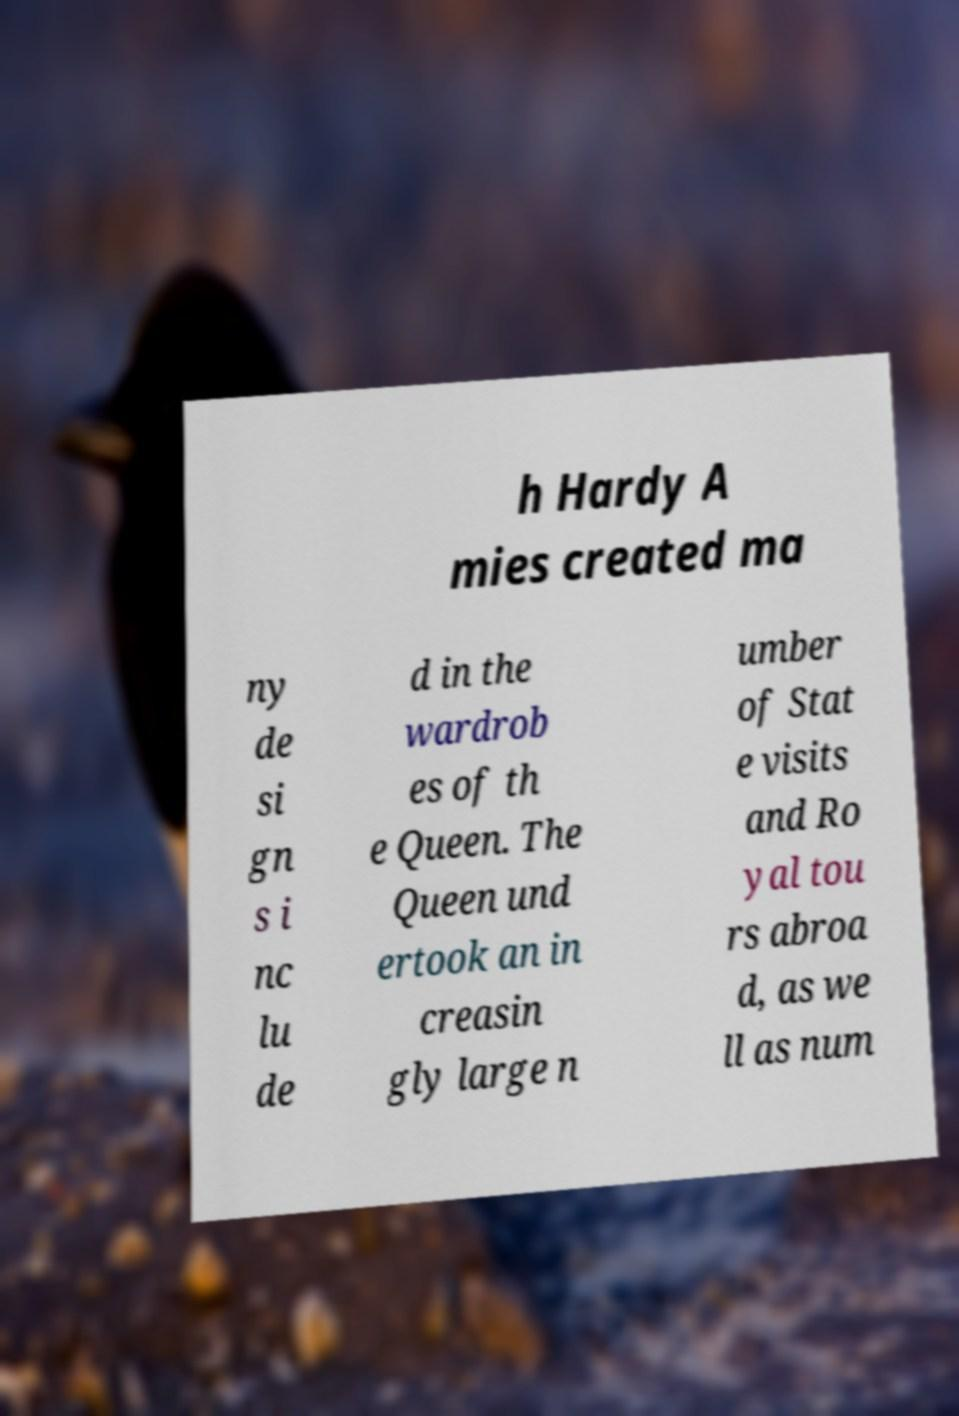Please identify and transcribe the text found in this image. h Hardy A mies created ma ny de si gn s i nc lu de d in the wardrob es of th e Queen. The Queen und ertook an in creasin gly large n umber of Stat e visits and Ro yal tou rs abroa d, as we ll as num 